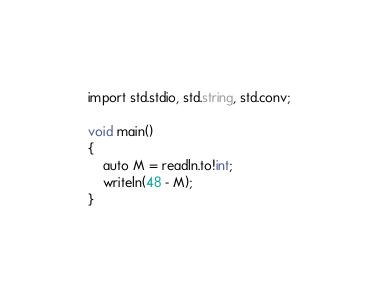Convert code to text. <code><loc_0><loc_0><loc_500><loc_500><_D_>import std.stdio, std.string, std.conv;

void main()
{
	auto M = readln.to!int;
	writeln(48 - M);
}</code> 